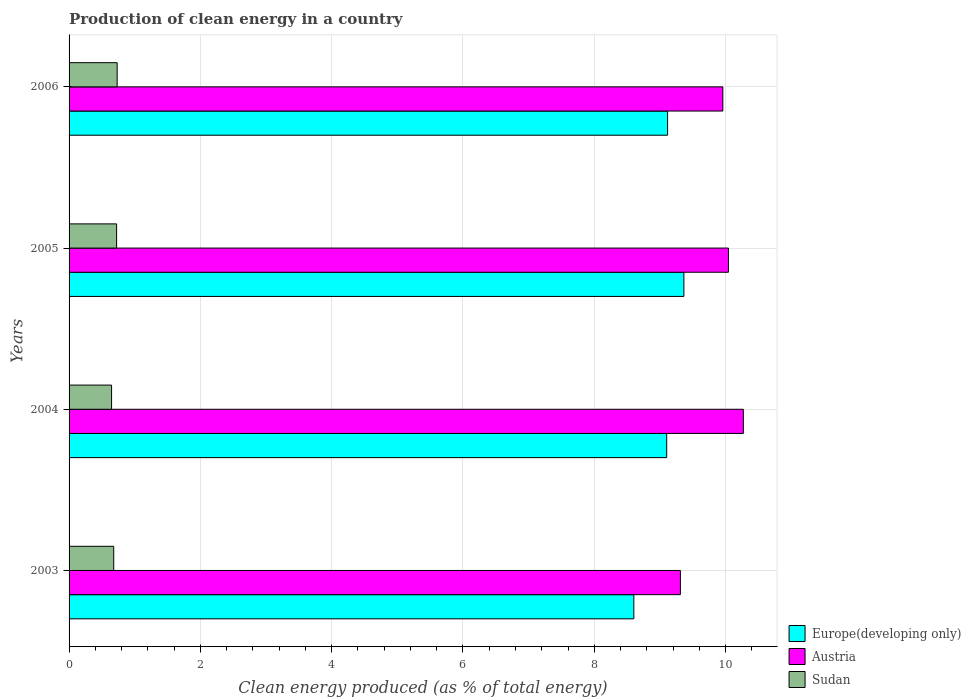How many different coloured bars are there?
Provide a short and direct response. 3. How many groups of bars are there?
Make the answer very short. 4. Are the number of bars per tick equal to the number of legend labels?
Offer a terse response. Yes. Are the number of bars on each tick of the Y-axis equal?
Make the answer very short. Yes. What is the label of the 1st group of bars from the top?
Ensure brevity in your answer.  2006. In how many cases, is the number of bars for a given year not equal to the number of legend labels?
Provide a succinct answer. 0. What is the percentage of clean energy produced in Sudan in 2006?
Offer a terse response. 0.73. Across all years, what is the maximum percentage of clean energy produced in Austria?
Give a very brief answer. 10.27. Across all years, what is the minimum percentage of clean energy produced in Europe(developing only)?
Provide a succinct answer. 8.6. What is the total percentage of clean energy produced in Sudan in the graph?
Your answer should be very brief. 2.78. What is the difference between the percentage of clean energy produced in Austria in 2003 and that in 2004?
Offer a very short reply. -0.96. What is the difference between the percentage of clean energy produced in Austria in 2005 and the percentage of clean energy produced in Europe(developing only) in 2003?
Your answer should be compact. 1.44. What is the average percentage of clean energy produced in Austria per year?
Your answer should be compact. 9.9. In the year 2004, what is the difference between the percentage of clean energy produced in Europe(developing only) and percentage of clean energy produced in Austria?
Ensure brevity in your answer.  -1.17. In how many years, is the percentage of clean energy produced in Sudan greater than 8.8 %?
Offer a very short reply. 0. What is the ratio of the percentage of clean energy produced in Europe(developing only) in 2004 to that in 2005?
Ensure brevity in your answer.  0.97. Is the percentage of clean energy produced in Austria in 2003 less than that in 2006?
Your response must be concise. Yes. Is the difference between the percentage of clean energy produced in Europe(developing only) in 2004 and 2006 greater than the difference between the percentage of clean energy produced in Austria in 2004 and 2006?
Your response must be concise. No. What is the difference between the highest and the second highest percentage of clean energy produced in Europe(developing only)?
Offer a terse response. 0.25. What is the difference between the highest and the lowest percentage of clean energy produced in Austria?
Make the answer very short. 0.96. In how many years, is the percentage of clean energy produced in Europe(developing only) greater than the average percentage of clean energy produced in Europe(developing only) taken over all years?
Give a very brief answer. 3. What does the 2nd bar from the top in 2005 represents?
Your response must be concise. Austria. Is it the case that in every year, the sum of the percentage of clean energy produced in Austria and percentage of clean energy produced in Sudan is greater than the percentage of clean energy produced in Europe(developing only)?
Your answer should be very brief. Yes. How many bars are there?
Provide a short and direct response. 12. Are all the bars in the graph horizontal?
Make the answer very short. Yes. How many years are there in the graph?
Your response must be concise. 4. Are the values on the major ticks of X-axis written in scientific E-notation?
Your answer should be very brief. No. Does the graph contain grids?
Your answer should be very brief. Yes. Where does the legend appear in the graph?
Offer a terse response. Bottom right. How many legend labels are there?
Offer a terse response. 3. How are the legend labels stacked?
Offer a very short reply. Vertical. What is the title of the graph?
Your response must be concise. Production of clean energy in a country. Does "United Kingdom" appear as one of the legend labels in the graph?
Give a very brief answer. No. What is the label or title of the X-axis?
Provide a succinct answer. Clean energy produced (as % of total energy). What is the label or title of the Y-axis?
Your response must be concise. Years. What is the Clean energy produced (as % of total energy) in Europe(developing only) in 2003?
Your answer should be very brief. 8.6. What is the Clean energy produced (as % of total energy) in Austria in 2003?
Offer a very short reply. 9.31. What is the Clean energy produced (as % of total energy) of Sudan in 2003?
Make the answer very short. 0.68. What is the Clean energy produced (as % of total energy) in Europe(developing only) in 2004?
Your response must be concise. 9.1. What is the Clean energy produced (as % of total energy) of Austria in 2004?
Make the answer very short. 10.27. What is the Clean energy produced (as % of total energy) in Sudan in 2004?
Ensure brevity in your answer.  0.65. What is the Clean energy produced (as % of total energy) in Europe(developing only) in 2005?
Provide a succinct answer. 9.36. What is the Clean energy produced (as % of total energy) of Austria in 2005?
Provide a short and direct response. 10.04. What is the Clean energy produced (as % of total energy) of Sudan in 2005?
Your answer should be compact. 0.72. What is the Clean energy produced (as % of total energy) in Europe(developing only) in 2006?
Provide a succinct answer. 9.12. What is the Clean energy produced (as % of total energy) in Austria in 2006?
Make the answer very short. 9.96. What is the Clean energy produced (as % of total energy) in Sudan in 2006?
Keep it short and to the point. 0.73. Across all years, what is the maximum Clean energy produced (as % of total energy) in Europe(developing only)?
Give a very brief answer. 9.36. Across all years, what is the maximum Clean energy produced (as % of total energy) of Austria?
Provide a short and direct response. 10.27. Across all years, what is the maximum Clean energy produced (as % of total energy) of Sudan?
Your response must be concise. 0.73. Across all years, what is the minimum Clean energy produced (as % of total energy) in Europe(developing only)?
Provide a succinct answer. 8.6. Across all years, what is the minimum Clean energy produced (as % of total energy) of Austria?
Provide a short and direct response. 9.31. Across all years, what is the minimum Clean energy produced (as % of total energy) of Sudan?
Offer a very short reply. 0.65. What is the total Clean energy produced (as % of total energy) in Europe(developing only) in the graph?
Ensure brevity in your answer.  36.19. What is the total Clean energy produced (as % of total energy) of Austria in the graph?
Give a very brief answer. 39.58. What is the total Clean energy produced (as % of total energy) of Sudan in the graph?
Give a very brief answer. 2.78. What is the difference between the Clean energy produced (as % of total energy) in Europe(developing only) in 2003 and that in 2004?
Offer a terse response. -0.5. What is the difference between the Clean energy produced (as % of total energy) in Austria in 2003 and that in 2004?
Give a very brief answer. -0.96. What is the difference between the Clean energy produced (as % of total energy) of Sudan in 2003 and that in 2004?
Make the answer very short. 0.03. What is the difference between the Clean energy produced (as % of total energy) of Europe(developing only) in 2003 and that in 2005?
Make the answer very short. -0.76. What is the difference between the Clean energy produced (as % of total energy) of Austria in 2003 and that in 2005?
Your answer should be very brief. -0.73. What is the difference between the Clean energy produced (as % of total energy) of Sudan in 2003 and that in 2005?
Provide a short and direct response. -0.04. What is the difference between the Clean energy produced (as % of total energy) of Europe(developing only) in 2003 and that in 2006?
Provide a succinct answer. -0.51. What is the difference between the Clean energy produced (as % of total energy) of Austria in 2003 and that in 2006?
Make the answer very short. -0.65. What is the difference between the Clean energy produced (as % of total energy) of Sudan in 2003 and that in 2006?
Your answer should be very brief. -0.05. What is the difference between the Clean energy produced (as % of total energy) in Europe(developing only) in 2004 and that in 2005?
Ensure brevity in your answer.  -0.26. What is the difference between the Clean energy produced (as % of total energy) of Austria in 2004 and that in 2005?
Provide a succinct answer. 0.23. What is the difference between the Clean energy produced (as % of total energy) of Sudan in 2004 and that in 2005?
Ensure brevity in your answer.  -0.08. What is the difference between the Clean energy produced (as % of total energy) in Europe(developing only) in 2004 and that in 2006?
Ensure brevity in your answer.  -0.01. What is the difference between the Clean energy produced (as % of total energy) in Austria in 2004 and that in 2006?
Your answer should be compact. 0.31. What is the difference between the Clean energy produced (as % of total energy) of Sudan in 2004 and that in 2006?
Provide a succinct answer. -0.08. What is the difference between the Clean energy produced (as % of total energy) in Europe(developing only) in 2005 and that in 2006?
Provide a short and direct response. 0.25. What is the difference between the Clean energy produced (as % of total energy) in Austria in 2005 and that in 2006?
Offer a terse response. 0.09. What is the difference between the Clean energy produced (as % of total energy) in Sudan in 2005 and that in 2006?
Your answer should be very brief. -0.01. What is the difference between the Clean energy produced (as % of total energy) in Europe(developing only) in 2003 and the Clean energy produced (as % of total energy) in Austria in 2004?
Ensure brevity in your answer.  -1.67. What is the difference between the Clean energy produced (as % of total energy) in Europe(developing only) in 2003 and the Clean energy produced (as % of total energy) in Sudan in 2004?
Ensure brevity in your answer.  7.95. What is the difference between the Clean energy produced (as % of total energy) of Austria in 2003 and the Clean energy produced (as % of total energy) of Sudan in 2004?
Make the answer very short. 8.66. What is the difference between the Clean energy produced (as % of total energy) of Europe(developing only) in 2003 and the Clean energy produced (as % of total energy) of Austria in 2005?
Make the answer very short. -1.44. What is the difference between the Clean energy produced (as % of total energy) of Europe(developing only) in 2003 and the Clean energy produced (as % of total energy) of Sudan in 2005?
Ensure brevity in your answer.  7.88. What is the difference between the Clean energy produced (as % of total energy) in Austria in 2003 and the Clean energy produced (as % of total energy) in Sudan in 2005?
Keep it short and to the point. 8.59. What is the difference between the Clean energy produced (as % of total energy) of Europe(developing only) in 2003 and the Clean energy produced (as % of total energy) of Austria in 2006?
Offer a very short reply. -1.36. What is the difference between the Clean energy produced (as % of total energy) of Europe(developing only) in 2003 and the Clean energy produced (as % of total energy) of Sudan in 2006?
Your answer should be very brief. 7.87. What is the difference between the Clean energy produced (as % of total energy) in Austria in 2003 and the Clean energy produced (as % of total energy) in Sudan in 2006?
Your response must be concise. 8.58. What is the difference between the Clean energy produced (as % of total energy) of Europe(developing only) in 2004 and the Clean energy produced (as % of total energy) of Austria in 2005?
Offer a very short reply. -0.94. What is the difference between the Clean energy produced (as % of total energy) in Europe(developing only) in 2004 and the Clean energy produced (as % of total energy) in Sudan in 2005?
Your answer should be very brief. 8.38. What is the difference between the Clean energy produced (as % of total energy) of Austria in 2004 and the Clean energy produced (as % of total energy) of Sudan in 2005?
Offer a terse response. 9.55. What is the difference between the Clean energy produced (as % of total energy) of Europe(developing only) in 2004 and the Clean energy produced (as % of total energy) of Austria in 2006?
Keep it short and to the point. -0.85. What is the difference between the Clean energy produced (as % of total energy) in Europe(developing only) in 2004 and the Clean energy produced (as % of total energy) in Sudan in 2006?
Make the answer very short. 8.37. What is the difference between the Clean energy produced (as % of total energy) of Austria in 2004 and the Clean energy produced (as % of total energy) of Sudan in 2006?
Your answer should be compact. 9.54. What is the difference between the Clean energy produced (as % of total energy) of Europe(developing only) in 2005 and the Clean energy produced (as % of total energy) of Austria in 2006?
Provide a succinct answer. -0.59. What is the difference between the Clean energy produced (as % of total energy) in Europe(developing only) in 2005 and the Clean energy produced (as % of total energy) in Sudan in 2006?
Provide a succinct answer. 8.63. What is the difference between the Clean energy produced (as % of total energy) of Austria in 2005 and the Clean energy produced (as % of total energy) of Sudan in 2006?
Give a very brief answer. 9.31. What is the average Clean energy produced (as % of total energy) in Europe(developing only) per year?
Keep it short and to the point. 9.05. What is the average Clean energy produced (as % of total energy) of Austria per year?
Offer a terse response. 9.9. What is the average Clean energy produced (as % of total energy) in Sudan per year?
Make the answer very short. 0.7. In the year 2003, what is the difference between the Clean energy produced (as % of total energy) in Europe(developing only) and Clean energy produced (as % of total energy) in Austria?
Make the answer very short. -0.71. In the year 2003, what is the difference between the Clean energy produced (as % of total energy) of Europe(developing only) and Clean energy produced (as % of total energy) of Sudan?
Give a very brief answer. 7.92. In the year 2003, what is the difference between the Clean energy produced (as % of total energy) in Austria and Clean energy produced (as % of total energy) in Sudan?
Offer a terse response. 8.63. In the year 2004, what is the difference between the Clean energy produced (as % of total energy) in Europe(developing only) and Clean energy produced (as % of total energy) in Austria?
Provide a short and direct response. -1.17. In the year 2004, what is the difference between the Clean energy produced (as % of total energy) in Europe(developing only) and Clean energy produced (as % of total energy) in Sudan?
Offer a terse response. 8.46. In the year 2004, what is the difference between the Clean energy produced (as % of total energy) in Austria and Clean energy produced (as % of total energy) in Sudan?
Ensure brevity in your answer.  9.62. In the year 2005, what is the difference between the Clean energy produced (as % of total energy) in Europe(developing only) and Clean energy produced (as % of total energy) in Austria?
Make the answer very short. -0.68. In the year 2005, what is the difference between the Clean energy produced (as % of total energy) of Europe(developing only) and Clean energy produced (as % of total energy) of Sudan?
Provide a succinct answer. 8.64. In the year 2005, what is the difference between the Clean energy produced (as % of total energy) in Austria and Clean energy produced (as % of total energy) in Sudan?
Your response must be concise. 9.32. In the year 2006, what is the difference between the Clean energy produced (as % of total energy) of Europe(developing only) and Clean energy produced (as % of total energy) of Austria?
Provide a short and direct response. -0.84. In the year 2006, what is the difference between the Clean energy produced (as % of total energy) in Europe(developing only) and Clean energy produced (as % of total energy) in Sudan?
Give a very brief answer. 8.38. In the year 2006, what is the difference between the Clean energy produced (as % of total energy) in Austria and Clean energy produced (as % of total energy) in Sudan?
Your response must be concise. 9.23. What is the ratio of the Clean energy produced (as % of total energy) of Europe(developing only) in 2003 to that in 2004?
Offer a terse response. 0.94. What is the ratio of the Clean energy produced (as % of total energy) in Austria in 2003 to that in 2004?
Offer a very short reply. 0.91. What is the ratio of the Clean energy produced (as % of total energy) in Sudan in 2003 to that in 2004?
Ensure brevity in your answer.  1.05. What is the ratio of the Clean energy produced (as % of total energy) in Europe(developing only) in 2003 to that in 2005?
Your response must be concise. 0.92. What is the ratio of the Clean energy produced (as % of total energy) in Austria in 2003 to that in 2005?
Ensure brevity in your answer.  0.93. What is the ratio of the Clean energy produced (as % of total energy) in Sudan in 2003 to that in 2005?
Your answer should be very brief. 0.94. What is the ratio of the Clean energy produced (as % of total energy) of Europe(developing only) in 2003 to that in 2006?
Offer a very short reply. 0.94. What is the ratio of the Clean energy produced (as % of total energy) in Austria in 2003 to that in 2006?
Offer a terse response. 0.94. What is the ratio of the Clean energy produced (as % of total energy) of Sudan in 2003 to that in 2006?
Your answer should be compact. 0.93. What is the ratio of the Clean energy produced (as % of total energy) of Austria in 2004 to that in 2005?
Offer a very short reply. 1.02. What is the ratio of the Clean energy produced (as % of total energy) in Sudan in 2004 to that in 2005?
Your response must be concise. 0.89. What is the ratio of the Clean energy produced (as % of total energy) of Austria in 2004 to that in 2006?
Provide a succinct answer. 1.03. What is the ratio of the Clean energy produced (as % of total energy) in Sudan in 2004 to that in 2006?
Your response must be concise. 0.88. What is the ratio of the Clean energy produced (as % of total energy) in Europe(developing only) in 2005 to that in 2006?
Your answer should be compact. 1.03. What is the ratio of the Clean energy produced (as % of total energy) of Austria in 2005 to that in 2006?
Your response must be concise. 1.01. What is the ratio of the Clean energy produced (as % of total energy) in Sudan in 2005 to that in 2006?
Offer a very short reply. 0.99. What is the difference between the highest and the second highest Clean energy produced (as % of total energy) of Europe(developing only)?
Give a very brief answer. 0.25. What is the difference between the highest and the second highest Clean energy produced (as % of total energy) in Austria?
Ensure brevity in your answer.  0.23. What is the difference between the highest and the second highest Clean energy produced (as % of total energy) of Sudan?
Offer a very short reply. 0.01. What is the difference between the highest and the lowest Clean energy produced (as % of total energy) in Europe(developing only)?
Ensure brevity in your answer.  0.76. What is the difference between the highest and the lowest Clean energy produced (as % of total energy) in Austria?
Offer a terse response. 0.96. What is the difference between the highest and the lowest Clean energy produced (as % of total energy) in Sudan?
Your answer should be very brief. 0.08. 